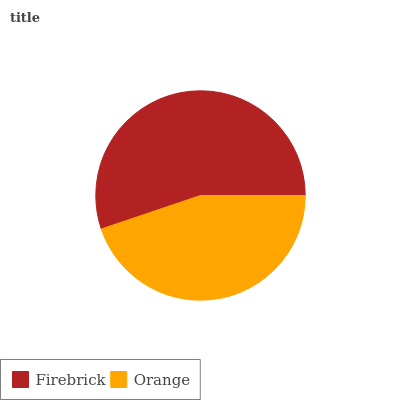Is Orange the minimum?
Answer yes or no. Yes. Is Firebrick the maximum?
Answer yes or no. Yes. Is Orange the maximum?
Answer yes or no. No. Is Firebrick greater than Orange?
Answer yes or no. Yes. Is Orange less than Firebrick?
Answer yes or no. Yes. Is Orange greater than Firebrick?
Answer yes or no. No. Is Firebrick less than Orange?
Answer yes or no. No. Is Firebrick the high median?
Answer yes or no. Yes. Is Orange the low median?
Answer yes or no. Yes. Is Orange the high median?
Answer yes or no. No. Is Firebrick the low median?
Answer yes or no. No. 